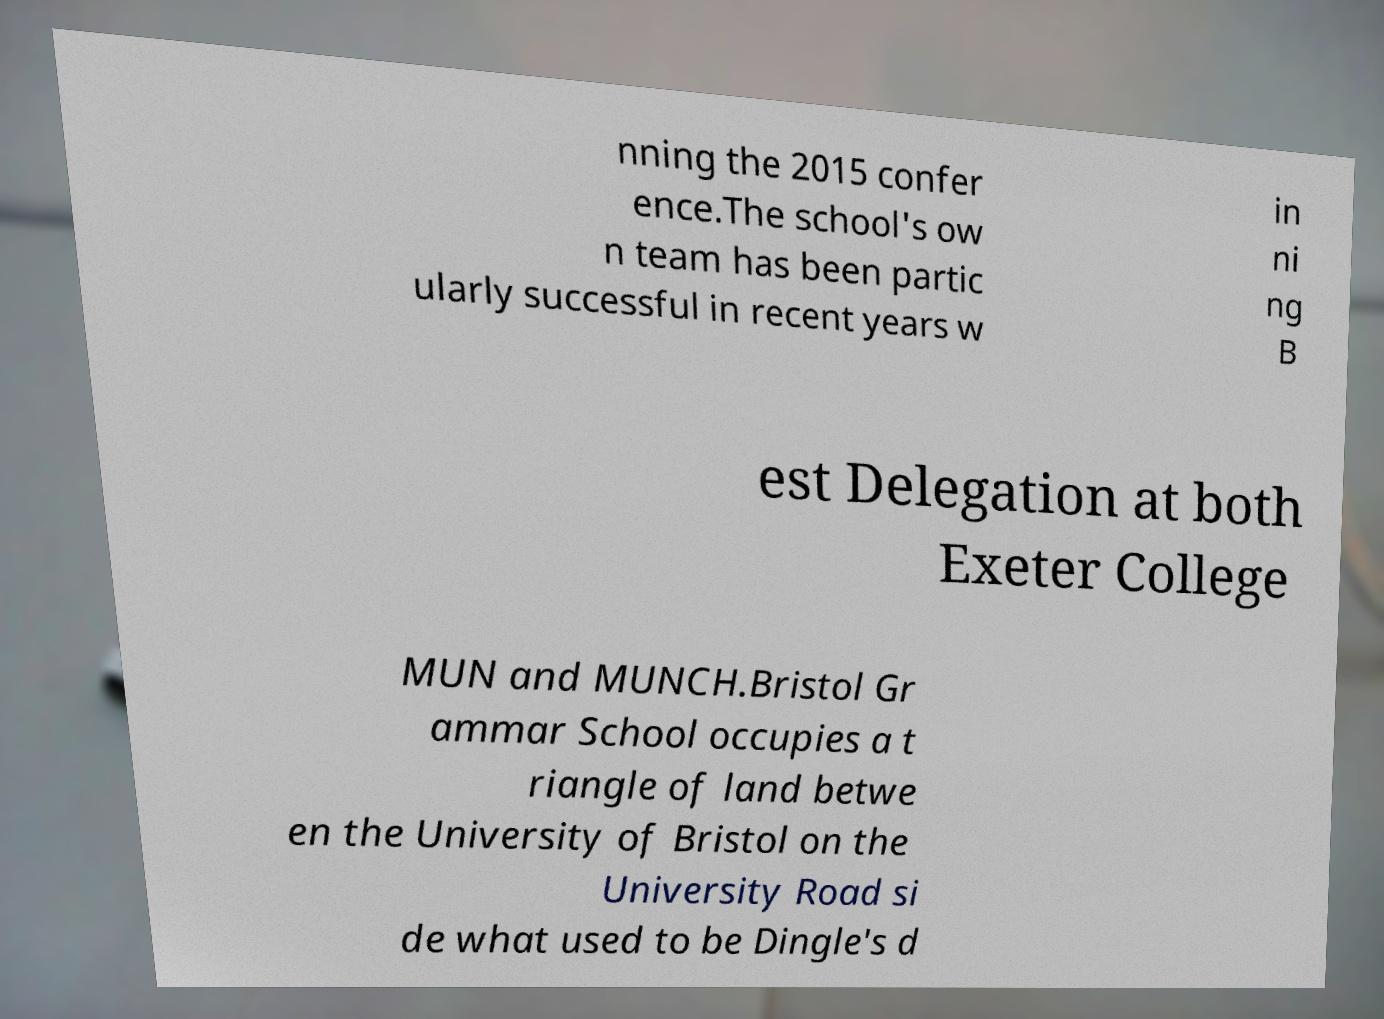Please read and relay the text visible in this image. What does it say? nning the 2015 confer ence.The school's ow n team has been partic ularly successful in recent years w in ni ng B est Delegation at both Exeter College MUN and MUNCH.Bristol Gr ammar School occupies a t riangle of land betwe en the University of Bristol on the University Road si de what used to be Dingle's d 